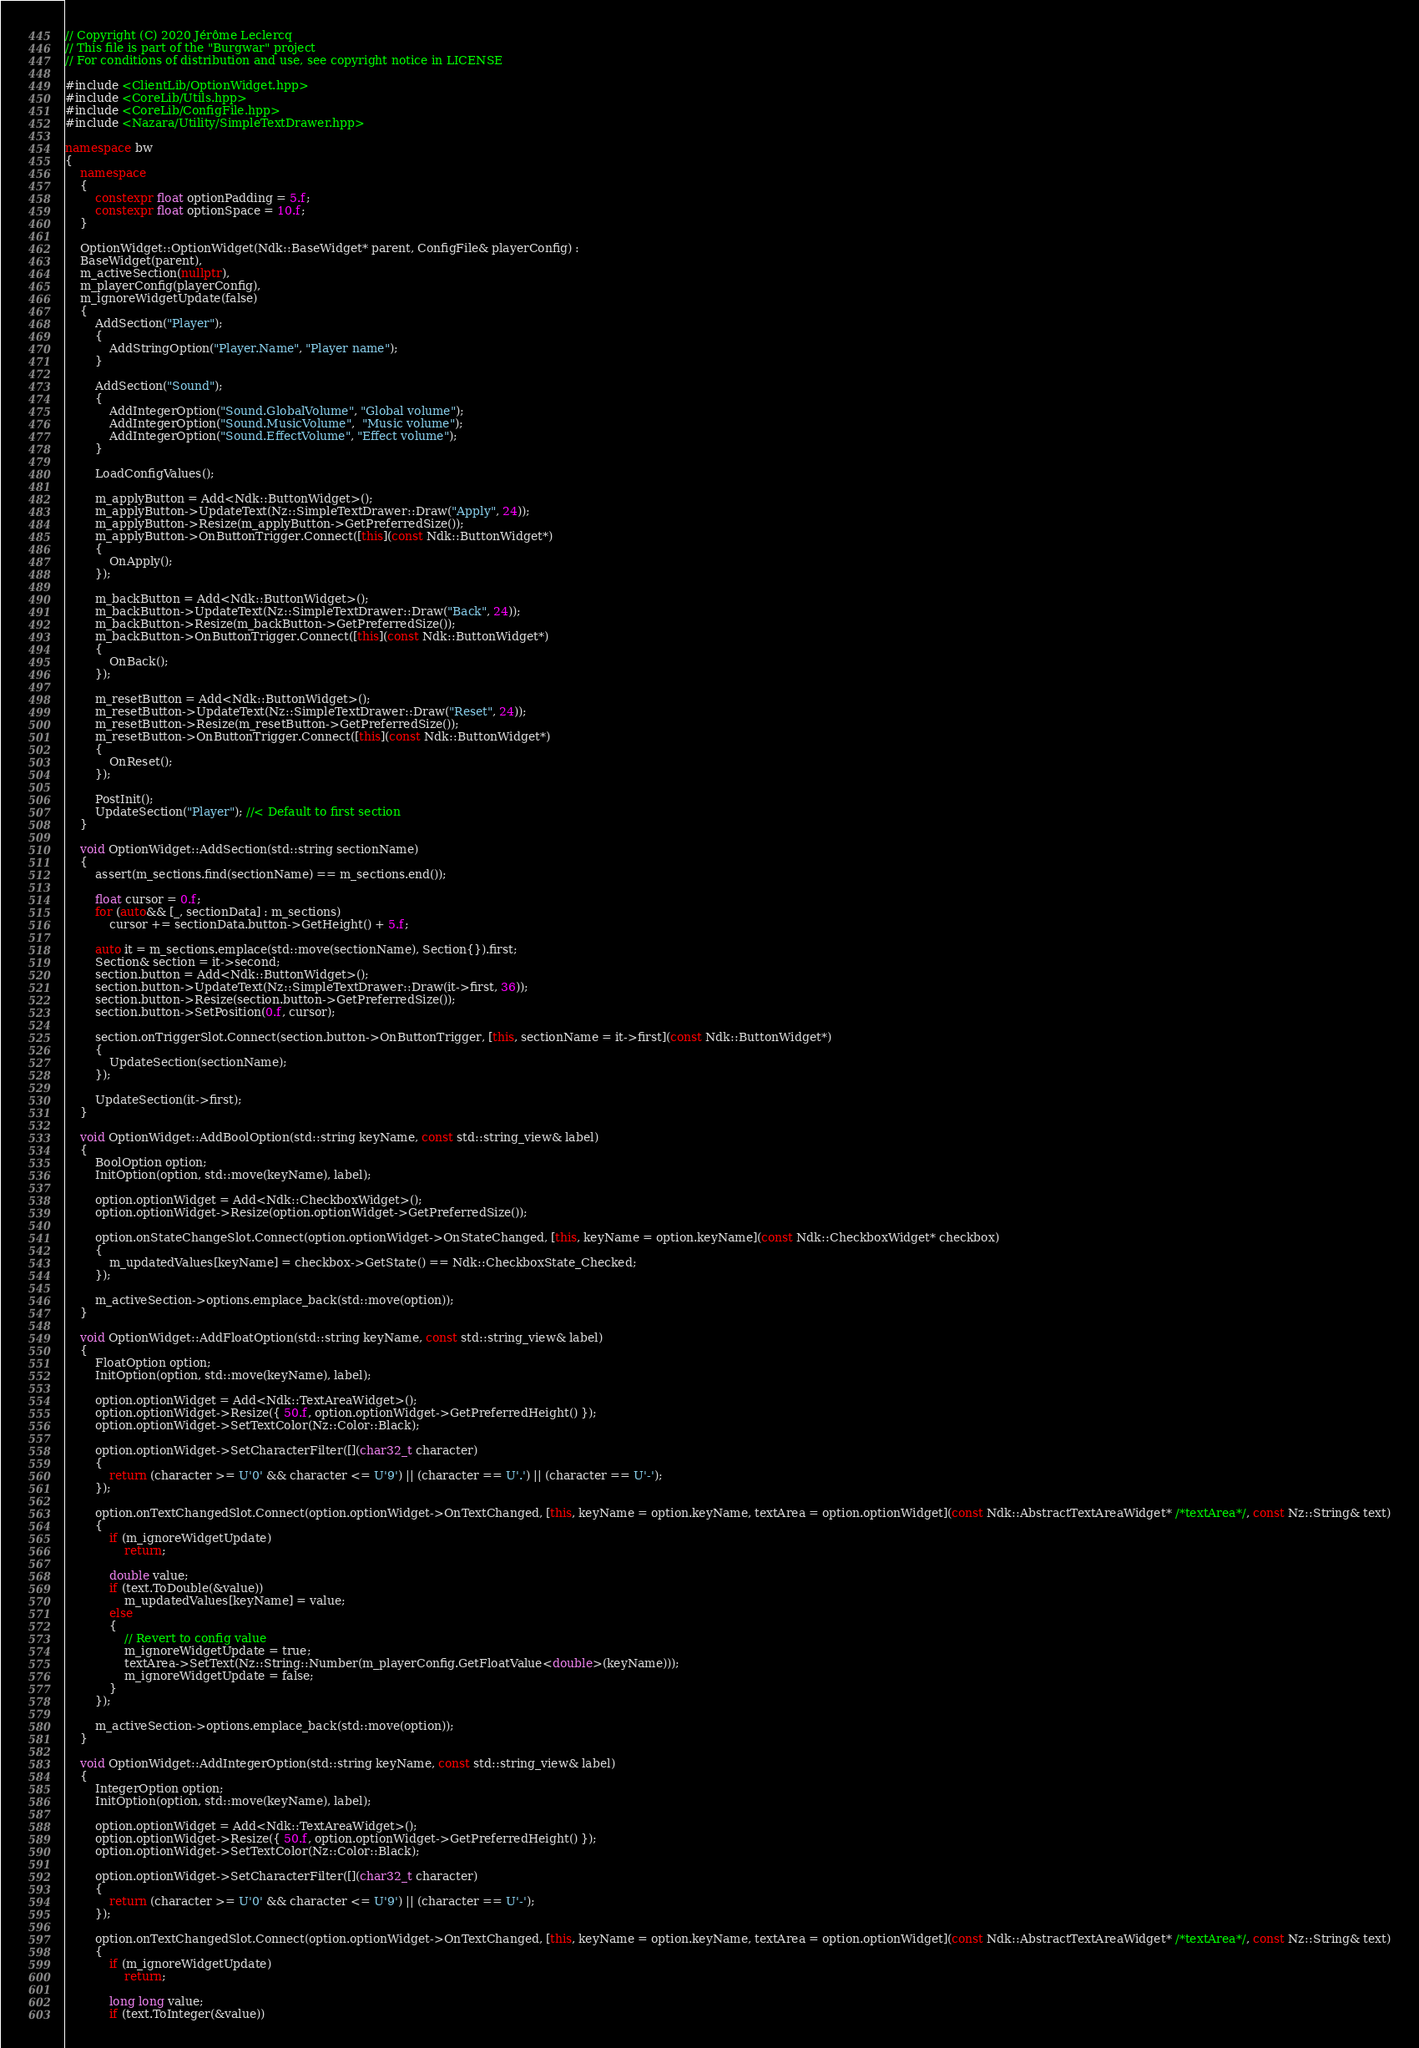Convert code to text. <code><loc_0><loc_0><loc_500><loc_500><_C++_>// Copyright (C) 2020 Jérôme Leclercq
// This file is part of the "Burgwar" project
// For conditions of distribution and use, see copyright notice in LICENSE

#include <ClientLib/OptionWidget.hpp>
#include <CoreLib/Utils.hpp>
#include <CoreLib/ConfigFile.hpp>
#include <Nazara/Utility/SimpleTextDrawer.hpp>

namespace bw
{
	namespace
	{
		constexpr float optionPadding = 5.f;
		constexpr float optionSpace = 10.f;
	}

	OptionWidget::OptionWidget(Ndk::BaseWidget* parent, ConfigFile& playerConfig) :
	BaseWidget(parent),
	m_activeSection(nullptr),
	m_playerConfig(playerConfig),
	m_ignoreWidgetUpdate(false)
	{
		AddSection("Player");
		{
			AddStringOption("Player.Name", "Player name");
		}

		AddSection("Sound");
		{
			AddIntegerOption("Sound.GlobalVolume", "Global volume");
			AddIntegerOption("Sound.MusicVolume",  "Music volume");
			AddIntegerOption("Sound.EffectVolume", "Effect volume");
		}

		LoadConfigValues();

		m_applyButton = Add<Ndk::ButtonWidget>();
		m_applyButton->UpdateText(Nz::SimpleTextDrawer::Draw("Apply", 24));
		m_applyButton->Resize(m_applyButton->GetPreferredSize());
		m_applyButton->OnButtonTrigger.Connect([this](const Ndk::ButtonWidget*)
		{
			OnApply();
		});
		
		m_backButton = Add<Ndk::ButtonWidget>();
		m_backButton->UpdateText(Nz::SimpleTextDrawer::Draw("Back", 24));
		m_backButton->Resize(m_backButton->GetPreferredSize());
		m_backButton->OnButtonTrigger.Connect([this](const Ndk::ButtonWidget*)
		{
			OnBack();
		});
		
		m_resetButton = Add<Ndk::ButtonWidget>();
		m_resetButton->UpdateText(Nz::SimpleTextDrawer::Draw("Reset", 24));
		m_resetButton->Resize(m_resetButton->GetPreferredSize());
		m_resetButton->OnButtonTrigger.Connect([this](const Ndk::ButtonWidget*)
		{
			OnReset();
		});

		PostInit();
		UpdateSection("Player"); //< Default to first section
	}
	
	void OptionWidget::AddSection(std::string sectionName)
	{
		assert(m_sections.find(sectionName) == m_sections.end());

		float cursor = 0.f;
		for (auto&& [_, sectionData] : m_sections)
			cursor += sectionData.button->GetHeight() + 5.f;

		auto it = m_sections.emplace(std::move(sectionName), Section{}).first;
		Section& section = it->second;
		section.button = Add<Ndk::ButtonWidget>();
		section.button->UpdateText(Nz::SimpleTextDrawer::Draw(it->first, 36));
		section.button->Resize(section.button->GetPreferredSize());
		section.button->SetPosition(0.f, cursor);

		section.onTriggerSlot.Connect(section.button->OnButtonTrigger, [this, sectionName = it->first](const Ndk::ButtonWidget*)
		{
			UpdateSection(sectionName);
		});

		UpdateSection(it->first);
	}
	
	void OptionWidget::AddBoolOption(std::string keyName, const std::string_view& label)
	{
		BoolOption option;
		InitOption(option, std::move(keyName), label);

		option.optionWidget = Add<Ndk::CheckboxWidget>();
		option.optionWidget->Resize(option.optionWidget->GetPreferredSize());

		option.onStateChangeSlot.Connect(option.optionWidget->OnStateChanged, [this, keyName = option.keyName](const Ndk::CheckboxWidget* checkbox)
		{
			m_updatedValues[keyName] = checkbox->GetState() == Ndk::CheckboxState_Checked;
		});

		m_activeSection->options.emplace_back(std::move(option));
	}

	void OptionWidget::AddFloatOption(std::string keyName, const std::string_view& label)
	{
		FloatOption option;
		InitOption(option, std::move(keyName), label);

		option.optionWidget = Add<Ndk::TextAreaWidget>();
		option.optionWidget->Resize({ 50.f, option.optionWidget->GetPreferredHeight() });
		option.optionWidget->SetTextColor(Nz::Color::Black);

		option.optionWidget->SetCharacterFilter([](char32_t character)
		{
			return (character >= U'0' && character <= U'9') || (character == U'.') || (character == U'-');
		});

		option.onTextChangedSlot.Connect(option.optionWidget->OnTextChanged, [this, keyName = option.keyName, textArea = option.optionWidget](const Ndk::AbstractTextAreaWidget* /*textArea*/, const Nz::String& text)
		{
			if (m_ignoreWidgetUpdate)
				return;

			double value;
			if (text.ToDouble(&value))
				m_updatedValues[keyName] = value;
			else
			{
				// Revert to config value
				m_ignoreWidgetUpdate = true;
				textArea->SetText(Nz::String::Number(m_playerConfig.GetFloatValue<double>(keyName)));
				m_ignoreWidgetUpdate = false;
			}
		});

		m_activeSection->options.emplace_back(std::move(option));
	}

	void OptionWidget::AddIntegerOption(std::string keyName, const std::string_view& label)
	{
		IntegerOption option;
		InitOption(option, std::move(keyName), label);

		option.optionWidget = Add<Ndk::TextAreaWidget>();
		option.optionWidget->Resize({ 50.f, option.optionWidget->GetPreferredHeight() });
		option.optionWidget->SetTextColor(Nz::Color::Black);
		
		option.optionWidget->SetCharacterFilter([](char32_t character)
		{
			return (character >= U'0' && character <= U'9') || (character == U'-');
		});

		option.onTextChangedSlot.Connect(option.optionWidget->OnTextChanged, [this, keyName = option.keyName, textArea = option.optionWidget](const Ndk::AbstractTextAreaWidget* /*textArea*/, const Nz::String& text)
		{
			if (m_ignoreWidgetUpdate)
				return;

			long long value;
			if (text.ToInteger(&value))</code> 